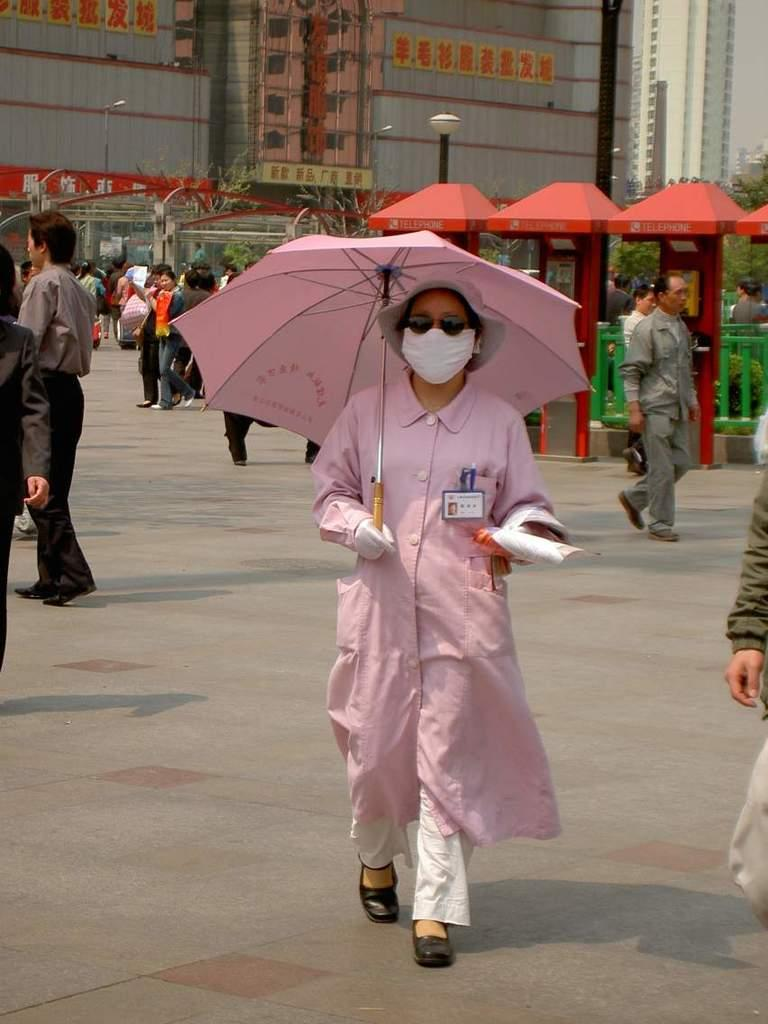What is the lady in the image wearing on her head? The lady is wearing a hat in the image. What type of protective gear is the lady wearing? The lady is wearing a mask in the image. What is the lady holding in her hand? The lady is holding an umbrella in her hand. What is the lady doing in the image? The lady is walking in the image. What can be seen in the background of the image? There are many people, sheds, and buildings in the background of the image. What type of desk can be seen in the image? There is no desk present in the image. What record is the lady listening to while walking? There is no record or music player mentioned in the image, and the lady is not shown listening to anything. 